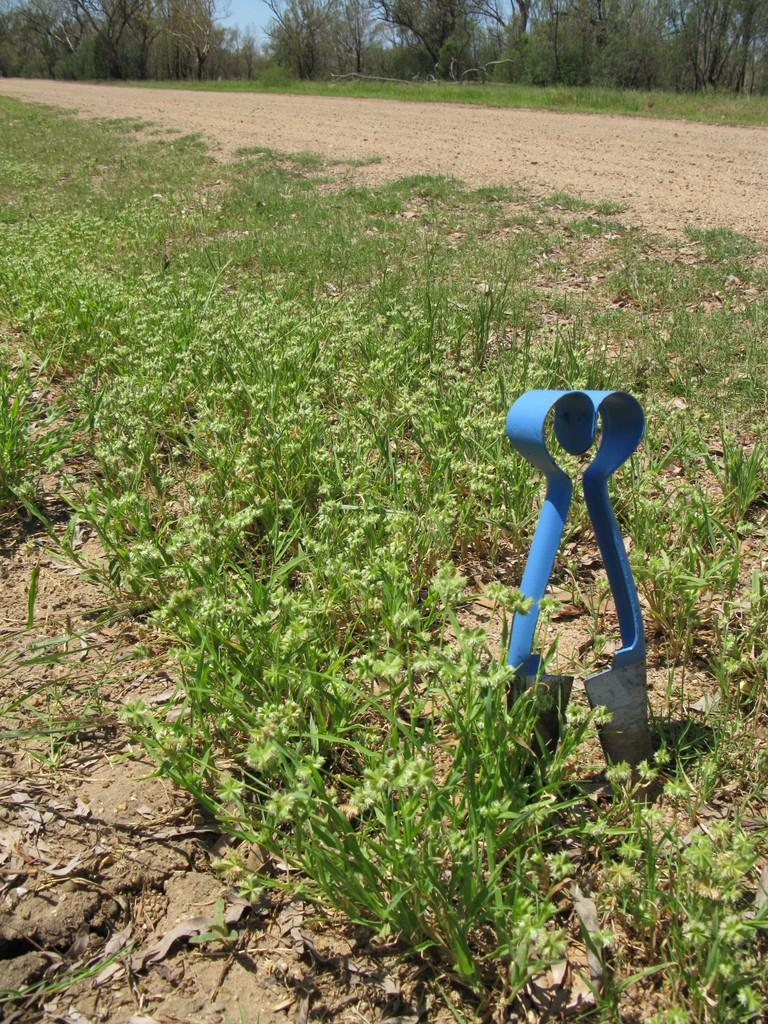What is the main subject in the image? There is an object in the image. What can be seen on the ground in the image? There are plants on the ground in the image. What type of vegetation is present in the image? There are trees in the image. What is visible in the background of the image? The sky is visible in the background of the image. How many sisters are present in the image? There are no people, let alone sisters, present in the image. 